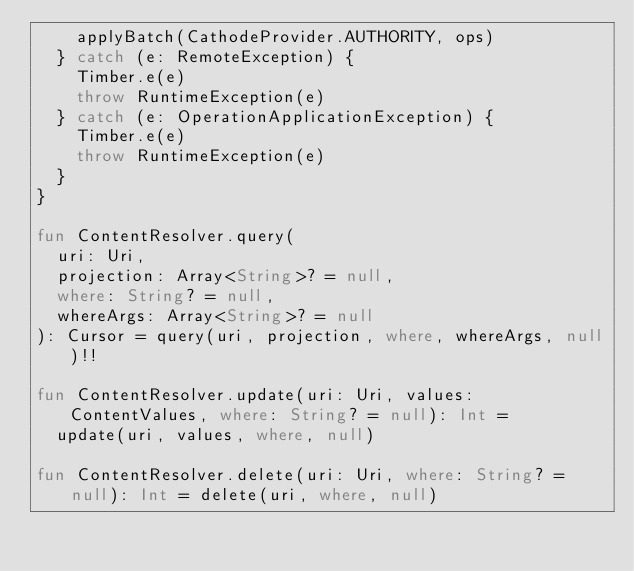Convert code to text. <code><loc_0><loc_0><loc_500><loc_500><_Kotlin_>    applyBatch(CathodeProvider.AUTHORITY, ops)
  } catch (e: RemoteException) {
    Timber.e(e)
    throw RuntimeException(e)
  } catch (e: OperationApplicationException) {
    Timber.e(e)
    throw RuntimeException(e)
  }
}

fun ContentResolver.query(
  uri: Uri,
  projection: Array<String>? = null,
  where: String? = null,
  whereArgs: Array<String>? = null
): Cursor = query(uri, projection, where, whereArgs, null)!!

fun ContentResolver.update(uri: Uri, values: ContentValues, where: String? = null): Int =
  update(uri, values, where, null)

fun ContentResolver.delete(uri: Uri, where: String? = null): Int = delete(uri, where, null)
</code> 